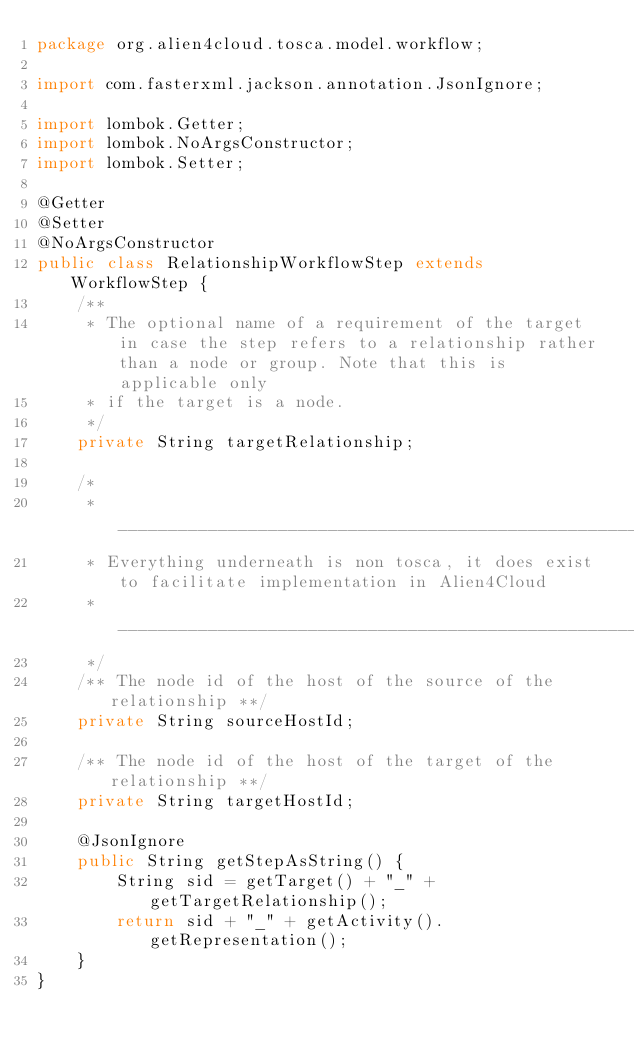<code> <loc_0><loc_0><loc_500><loc_500><_Java_>package org.alien4cloud.tosca.model.workflow;

import com.fasterxml.jackson.annotation.JsonIgnore;

import lombok.Getter;
import lombok.NoArgsConstructor;
import lombok.Setter;

@Getter
@Setter
@NoArgsConstructor
public class RelationshipWorkflowStep extends WorkflowStep {
    /**
     * The optional name of a requirement of the target in case the step refers to a relationship rather than a node or group. Note that this is applicable only
     * if the target is a node.
     */
    private String targetRelationship;

    /*
     * ________________________________________________________________________________________________
     * Everything underneath is non tosca, it does exist to facilitate implementation in Alien4Cloud
     * ________________________________________________________________________________________________
     */
    /** The node id of the host of the source of the relationship **/
    private String sourceHostId;

    /** The node id of the host of the target of the relationship **/
    private String targetHostId;

    @JsonIgnore
    public String getStepAsString() {
        String sid = getTarget() + "_" + getTargetRelationship();
        return sid + "_" + getActivity().getRepresentation();
    }
}
</code> 